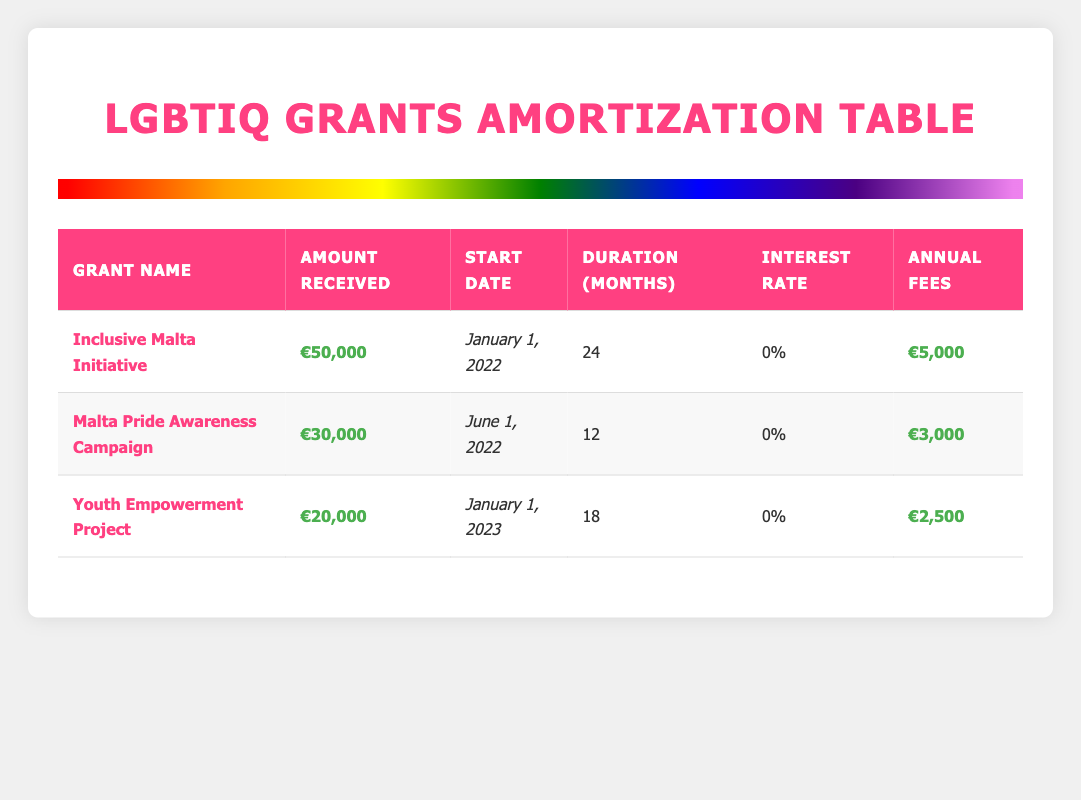What is the total amount received from the grants? To find the total amount received from the grants, I will add the amounts from each grant: €50,000 + €30,000 + €20,000 = €100,000.
Answer: €100,000 Which grant has the highest annual fees? I will compare the annual fees for each grant: €5,000 for Inclusive Malta Initiative, €3,000 for Malta Pride Awareness Campaign, and €2,500 for Youth Empowerment Project. The highest is €5,000.
Answer: Inclusive Malta Initiative Does the Youth Empowerment Project have a longer duration than the Malta Pride Awareness Campaign? The duration of the Youth Empowerment Project is 18 months, while the Malta Pride Awareness Campaign has a duration of 12 months. Since 18 is greater than 12, the statement is true.
Answer: Yes What is the average annual fee across all grants? I will first sum all the annual fees: €5,000 + €3,000 + €2,500 = €10,500. Then, I will divide this total by the number of grants (3): €10,500 / 3 = €3,500.
Answer: €3,500 Which grant started first and what was its start date? The grant that started first is the Inclusive Malta Initiative, which has a start date of January 1, 2022.
Answer: Inclusive Malta Initiative, January 1, 2022 Is there an interest rate applied to any of the grants? Looking at the interest rate column for each grant, all grants list 0%. Therefore, no grants have an interest rate applied.
Answer: No What is the total duration of all grants combined? I will add the duration months from each grant: 24 months (Inclusive Malta Initiative) + 12 months (Malta Pride Awareness Campaign) + 18 months (Youth Empowerment Project) = 54 months.
Answer: 54 months How many grants have an annual fee of €3,000 or more? I will count the grants with annual fees equal to or greater than €3,000: €5,000 (Inclusive Malta Initiative) and €3,000 (Malta Pride Awareness Campaign). This counts as 2 grants.
Answer: 2 grants 